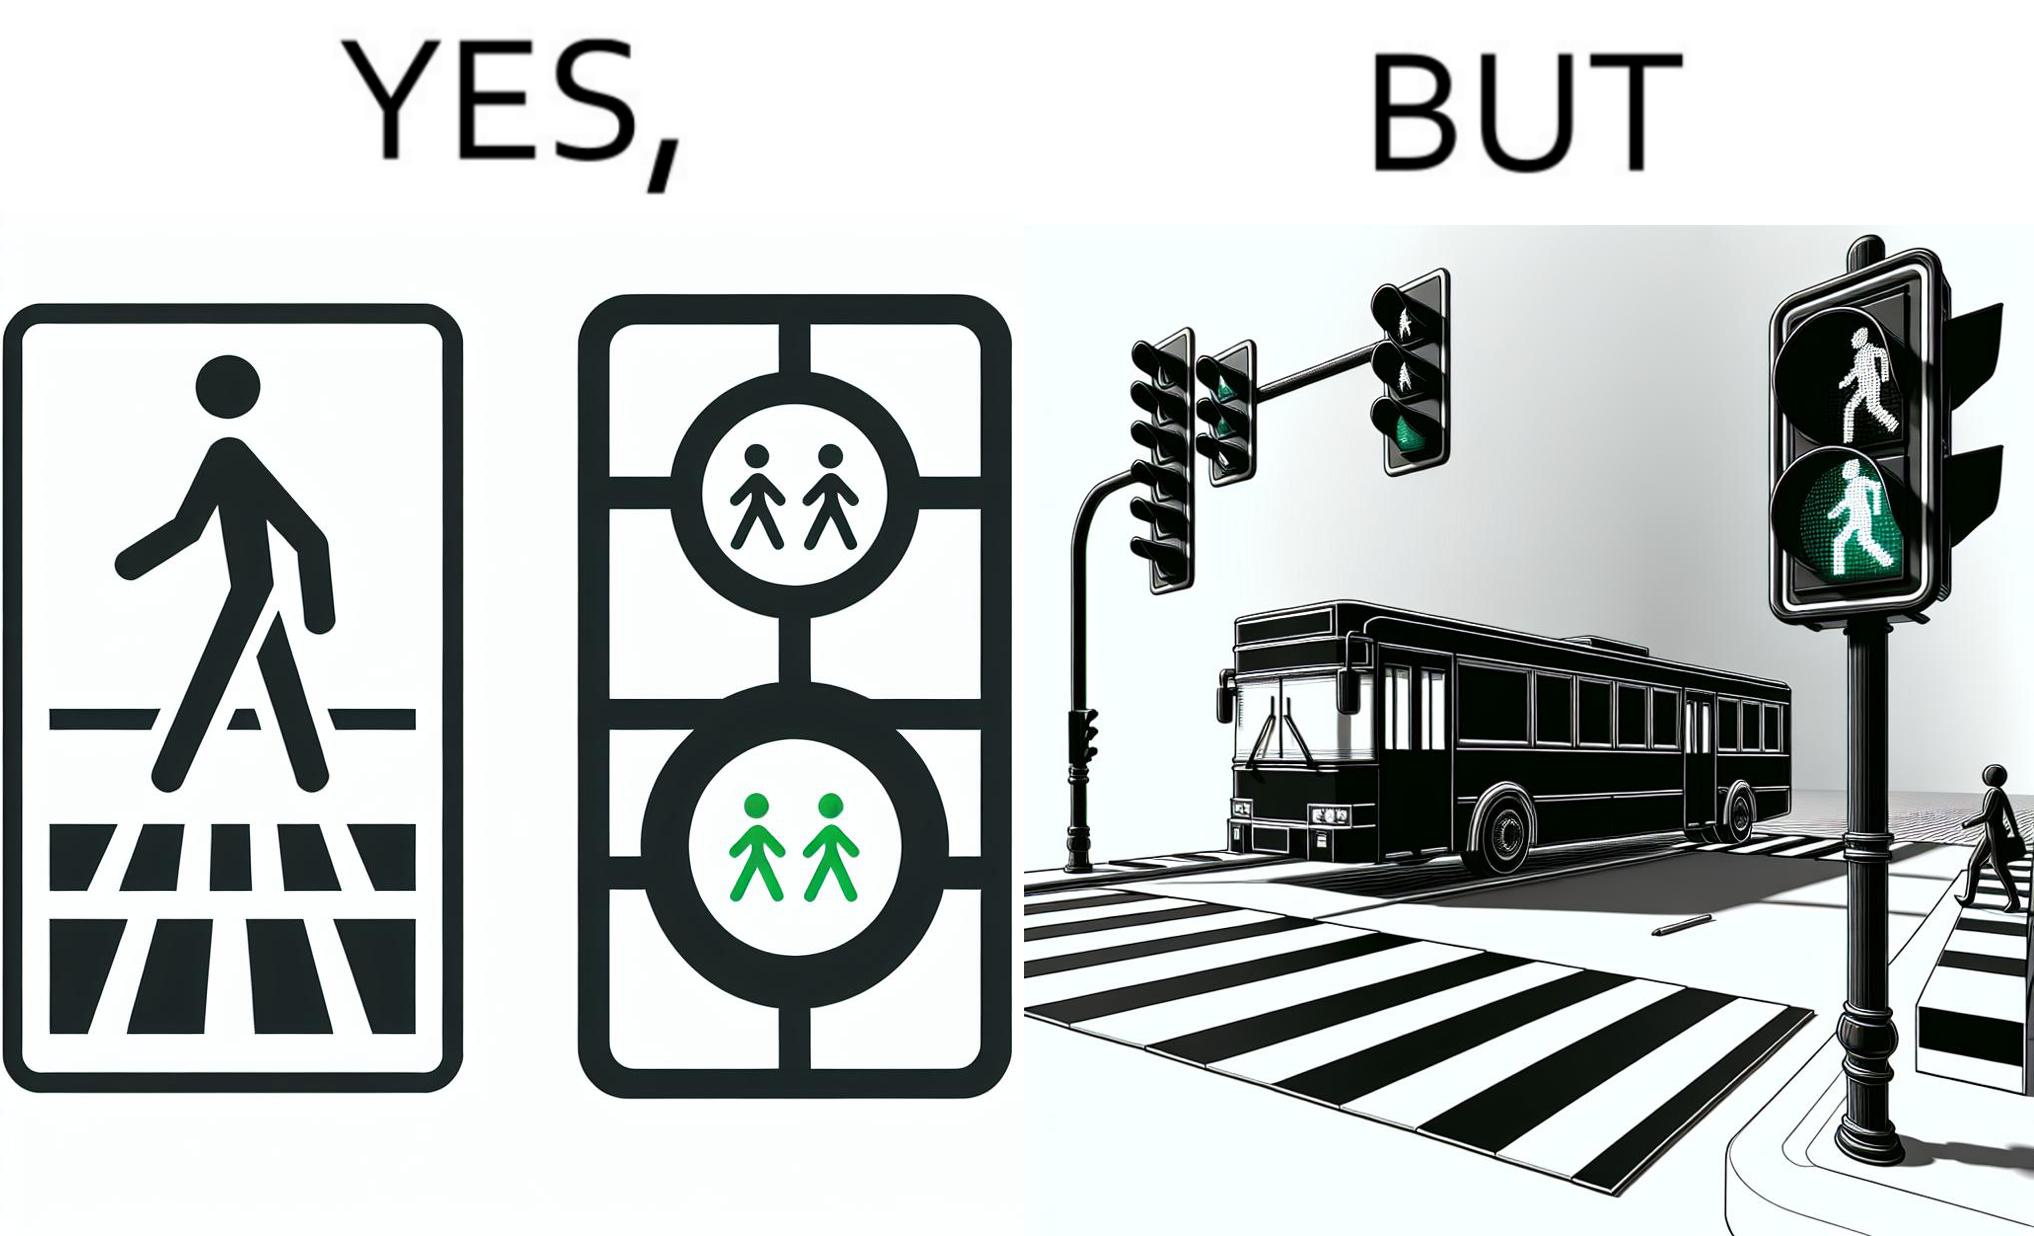Describe the content of this image. The image is ironic, because even when the signal is green for the pedestrians but they can't cross the road because of the vehicles standing on the zebra crossing 